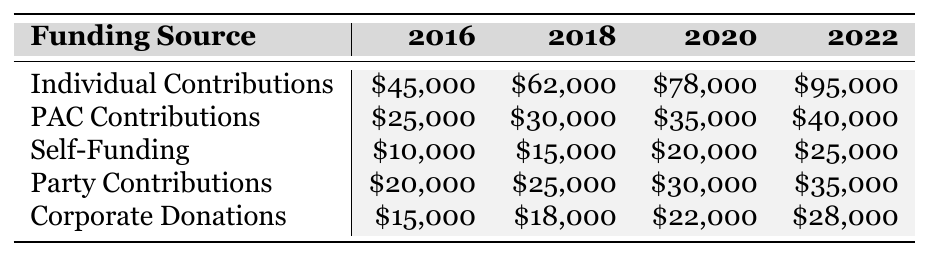What is the highest funding source for Mr. Hudgins in the year 2022? Looking at the table for the year 2022, the funding source with the highest amount is Individual Contributions, which total $95,000.
Answer: Individual Contributions How much did Mr. Hudgins receive from PAC Contributions in 2020? In the table under the 2020 column for PAC Contributions, the amount is $35,000.
Answer: $35,000 What is the total amount of self-funding across all election cycles? To find the total amount of Self-Funding, I sum the values: $10,000 + $15,000 + $20,000 + $25,000 = $70,000.
Answer: $70,000 Has the amount from Corporate Donations increased every election cycle? Observing the Corporate Donations row, the amounts are $15,000 in 2016, $18,000 in 2018, $22,000 in 2020, and $28,000 in 2022, showing consistent increases.
Answer: Yes What is the average amount of funding received from Party Contributions over the four election cycles? Summing the Party Contributions amounts: $20,000 + $25,000 + $30,000 + $35,000 = $110,000. Dividing by 4 gives an average of $110,000 / 4 = $27,500.
Answer: $27,500 What was the difference in Individual Contributions between 2016 and 2022? The value for Individual Contributions in 2022 is $95,000 and in 2016 is $45,000. The difference is $95,000 - $45,000 = $50,000.
Answer: $50,000 Which funding source had the greatest increase in total amount from 2016 to 2022? Calculating the increases: Individual Contributions: $95,000 - $45,000 = $50,000; PAC Contributions: $40,000 - $25,000 = $15,000; Self-Funding: $25,000 - $10,000 = $15,000; Party Contributions: $35,000 - $20,000 = $15,000; Corporate Donations: $28,000 - $15,000 = $13,000. Individual Contributions had the greatest increase of $50,000.
Answer: Individual Contributions What was the total amount received from all funding sources in 2020? To find the total for 2020, I sum the contributions from each source: $78,000 (Individual) + $35,000 (PAC) + $20,000 (Self-Funding) + $30,000 (Party) + $22,000 (Corporate) = $185,000.
Answer: $185,000 What funding source contributed the least amount in 2016? In 2016, looking at the amounts, Self-Funding at $10,000 is the least among all sources listed.
Answer: Self-Funding Did Mr. Hudgins rely more on Individual Contributions than all other sources combined in 2022? In 2022, Individual Contributions amount to $95,000. Summing the others: PAC ($40,000) + Self-Funding ($25,000) + Party ($35,000) + Corporate ($28,000) gives $128,000 combined. Since $95,000 is less than $128,000, he did not rely more on Individual Contributions.
Answer: No 